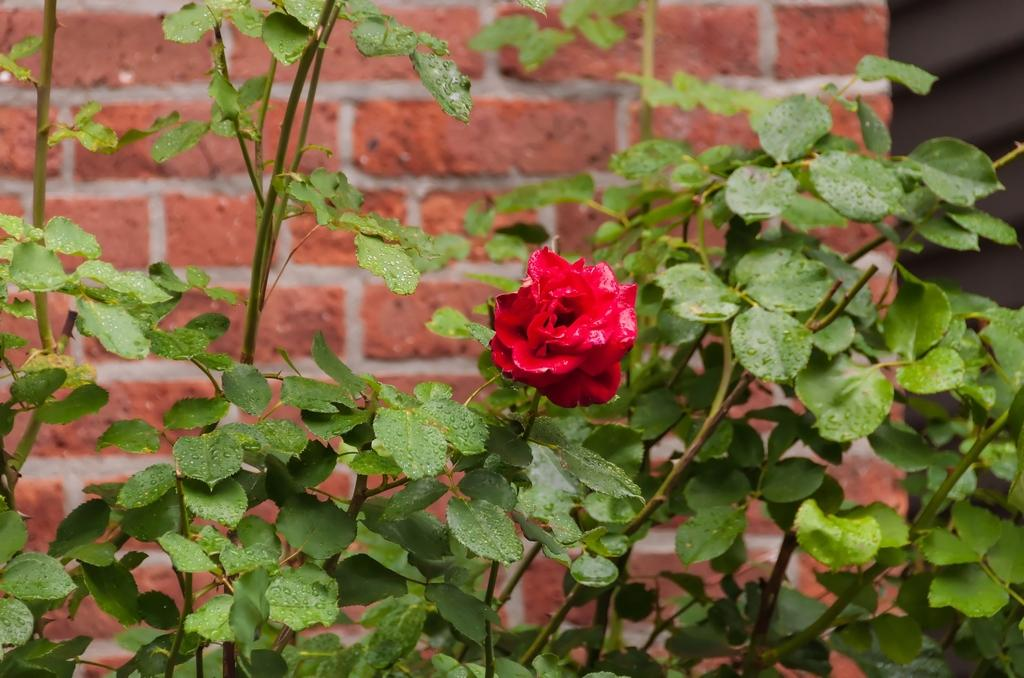What type of living organisms can be seen in the image? Plants are visible in the image. Is there a specific type of flower among the plants? Yes, there is a red color flower in the image. Where is the red color flower located in the image? The red color flower is in the center of the image. What can be seen in the background of the image? There is a wall in the background of the image. Can you see any goldfish swimming in the image? There are no goldfish present in the image. What type of terrain surrounds the plants in the image? The provided facts do not mention any specific terrain surrounding the plants; we only know that there is a wall in the background. 